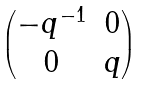<formula> <loc_0><loc_0><loc_500><loc_500>\begin{pmatrix} - q ^ { - 1 } & 0 \\ 0 & q \end{pmatrix}</formula> 